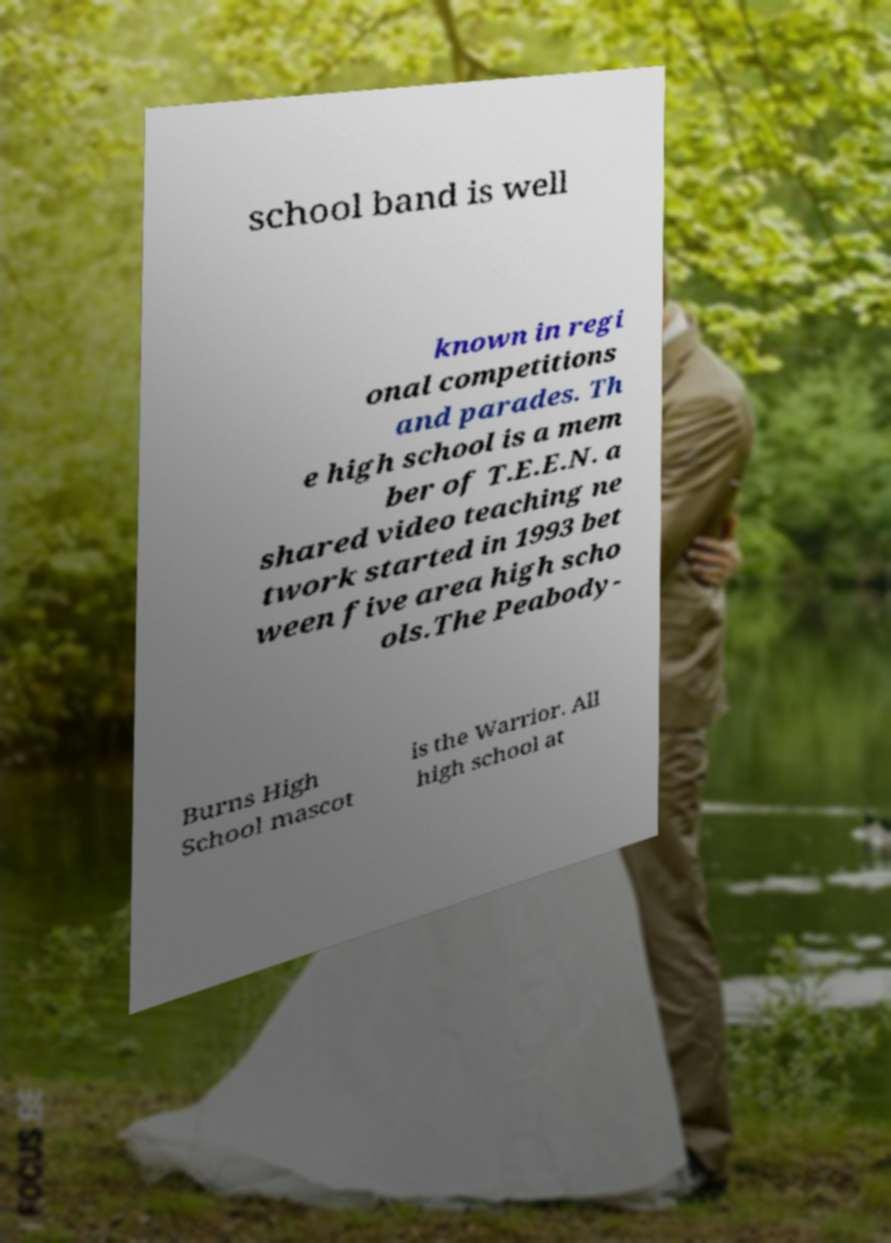There's text embedded in this image that I need extracted. Can you transcribe it verbatim? school band is well known in regi onal competitions and parades. Th e high school is a mem ber of T.E.E.N. a shared video teaching ne twork started in 1993 bet ween five area high scho ols.The Peabody- Burns High School mascot is the Warrior. All high school at 